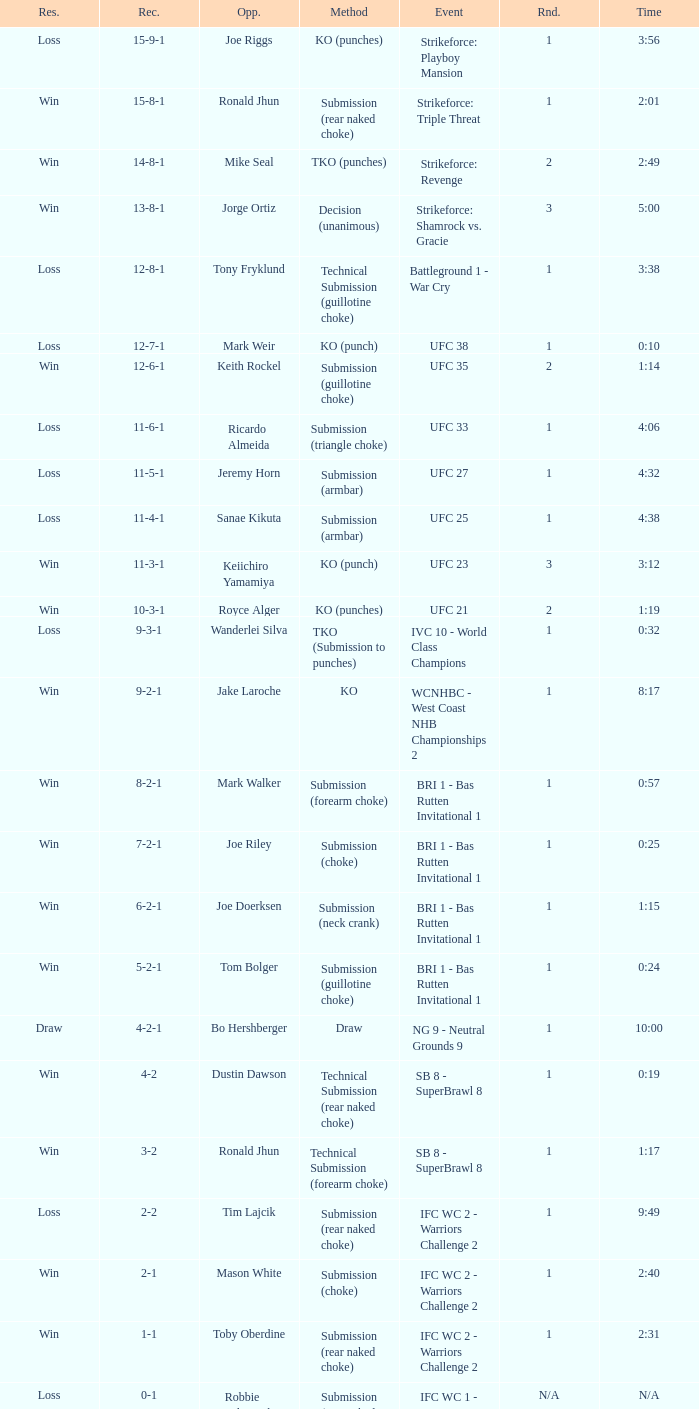Who was the opponent when the fight had a time of 0:10? Mark Weir. 